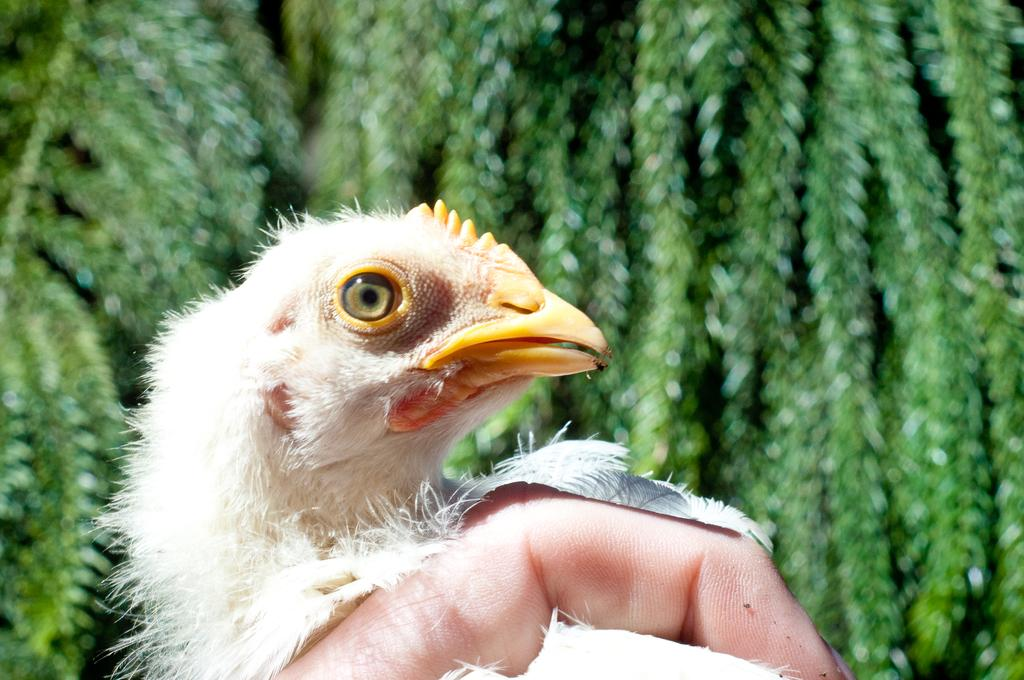What is the main subject in the foreground of the image? There is a bird in the foreground of the image. What else can be seen at the bottom of the image? There is a finger of a person at the bottom of the image. What type of environment is depicted in the background of the image? There is greenery in the background of the image. What does the caption say about the bird in the image? There is no caption present in the image, so it is not possible to answer that question. 